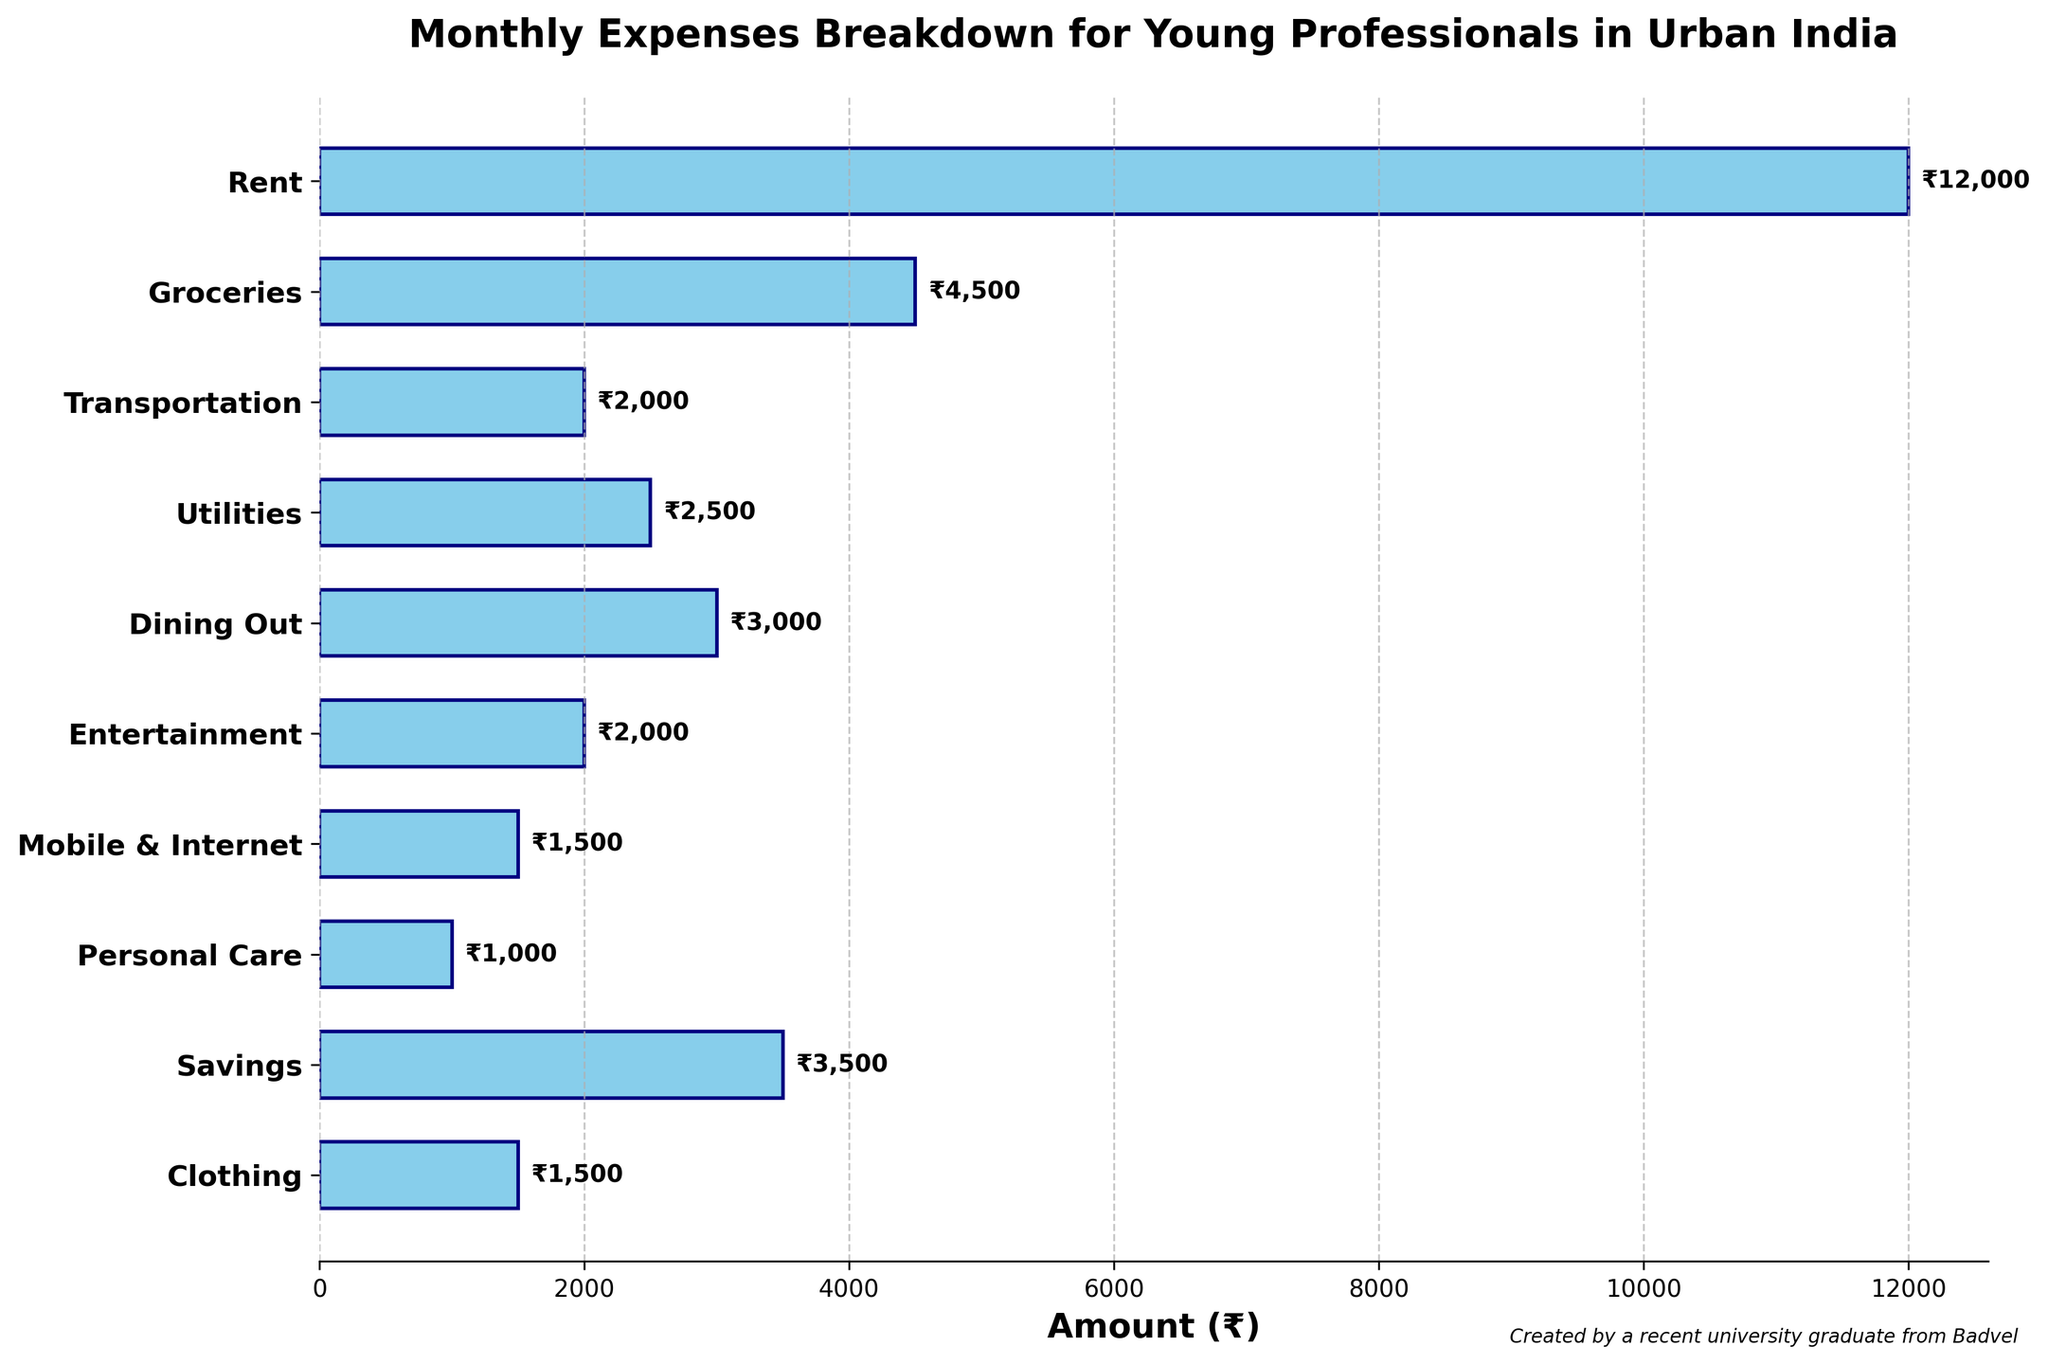What is the title of the figure? The title is placed at the top of the figure and provides a brief description of the content it represents. It usually gives an overview of what the chart is about.
Answer: Monthly Expenses Breakdown for Young Professionals in Urban India Which category has the highest expense? The highest bar in the horizontal bar chart corresponds to the category with the highest expense, which is visually evident.
Answer: Rent How much is spent on Groceries? Look for the bar labeled "Groceries" on the y-axis and read the numeric value next to or on the bar.
Answer: ₹4,500 What is the difference in expense between Entertainment and Dining Out? Find the bar heights for both categories "Entertainment" and "Dining Out". Subtract the smaller value from the larger one. Dining Out: ₹3,000; Entertainment: ₹2,000; Difference = ₹3,000 - ₹2,000
Answer: ₹1,000 Which category has lower expenses, Transportation or Utilities? Compare the lengths of the bars labeled "Transportation" and "Utilities". The shorter bar represents the category with lower expenses. Transportation: ₹2,000; Utilities: ₹2,500
Answer: Transportation What percentage of the total monthly expenses is spent on Savings? Calculate the total expenses by summing all the bar values. Then find the fraction of the total expense attributed to Savings and convert it to a percentage. Total: ₹12000 + ₹4500 + ₹2000 + ₹2500 + ₹3000 + ₹2000 + ₹1500 + ₹1000 + ₹3500 + ₹1500 = ₹32,500 Savings: ₹3,500; Percentage = (₹3,500 / ₹32,500) * 100
Answer: ~10.77% Which categories have expenses less than ₹2,000? Look for the bars with heights less than ₹2,000. Identify the corresponding categories on the y-axis.
Answer: Mobile & Internet, Personal Care, and Clothing What is the combined expense for Rent and Savings? Locate the bars for Rent and Savings, then add their values together. Rent: ₹12,000; Savings: ₹3,500; Combined Expense = ₹12,000 + ₹3,500
Answer: ₹15,500 Are there more categories with expenses above ₹3,000 or below ₹3,000? Count the number of bars above ₹3,000 and those below ₹3,000. Compare these counts to see which group has more categories. Above ₹3,000: Rent, Groceries; Below ₹3,000: Transportation, Utilities, Dining Out, Entertainment, Mobile & Internet, Personal Care, Clothing, Savings
Answer: Below ₹3,000 